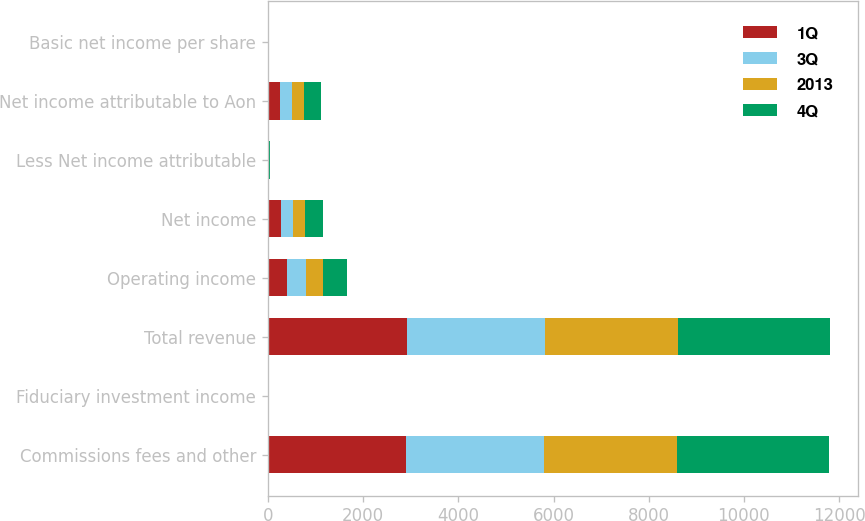<chart> <loc_0><loc_0><loc_500><loc_500><stacked_bar_chart><ecel><fcel>Commissions fees and other<fcel>Fiduciary investment income<fcel>Total revenue<fcel>Operating income<fcel>Net income<fcel>Less Net income attributable<fcel>Net income attributable to Aon<fcel>Basic net income per share<nl><fcel>1Q<fcel>2908<fcel>7<fcel>2915<fcel>410<fcel>272<fcel>11<fcel>261<fcel>0.82<nl><fcel>3Q<fcel>2891<fcel>6<fcel>2897<fcel>382<fcel>252<fcel>11<fcel>241<fcel>0.77<nl><fcel>2013<fcel>2786<fcel>8<fcel>2794<fcel>364<fcel>264<fcel>8<fcel>256<fcel>0.83<nl><fcel>4Q<fcel>3202<fcel>7<fcel>3209<fcel>515<fcel>360<fcel>5<fcel>355<fcel>1.16<nl></chart> 